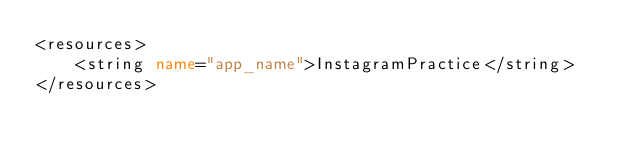Convert code to text. <code><loc_0><loc_0><loc_500><loc_500><_XML_><resources>
    <string name="app_name">InstagramPractice</string>
</resources></code> 